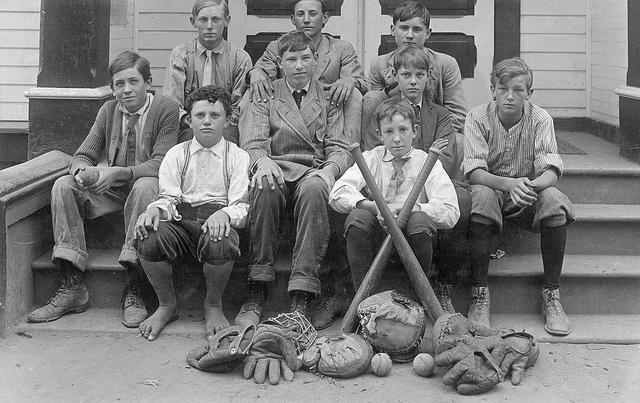How many people can be seen?
Give a very brief answer. 9. How many baseball gloves are in the picture?
Give a very brief answer. 5. How many baseball bats can you see?
Give a very brief answer. 2. 